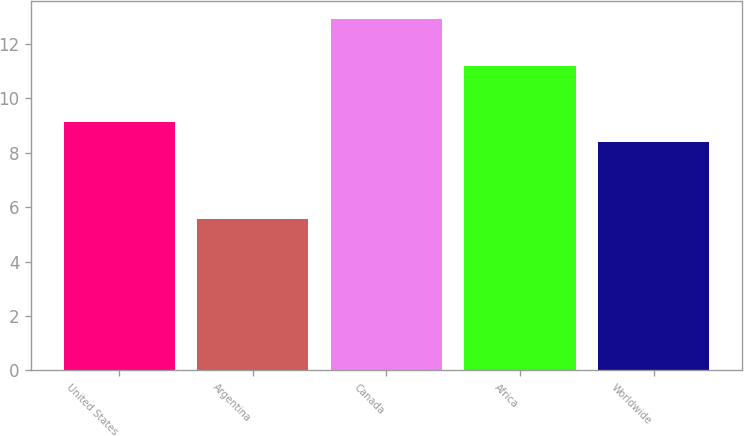Convert chart to OTSL. <chart><loc_0><loc_0><loc_500><loc_500><bar_chart><fcel>United States<fcel>Argentina<fcel>Canada<fcel>Africa<fcel>Worldwide<nl><fcel>9.12<fcel>5.56<fcel>12.93<fcel>11.19<fcel>8.38<nl></chart> 